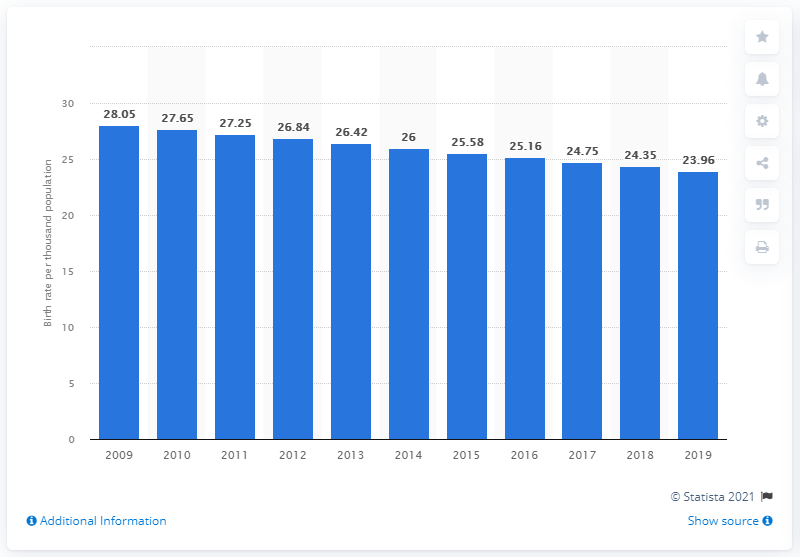Point out several critical features in this image. In 2019, Haiti's crude birth rate was 23.96. 